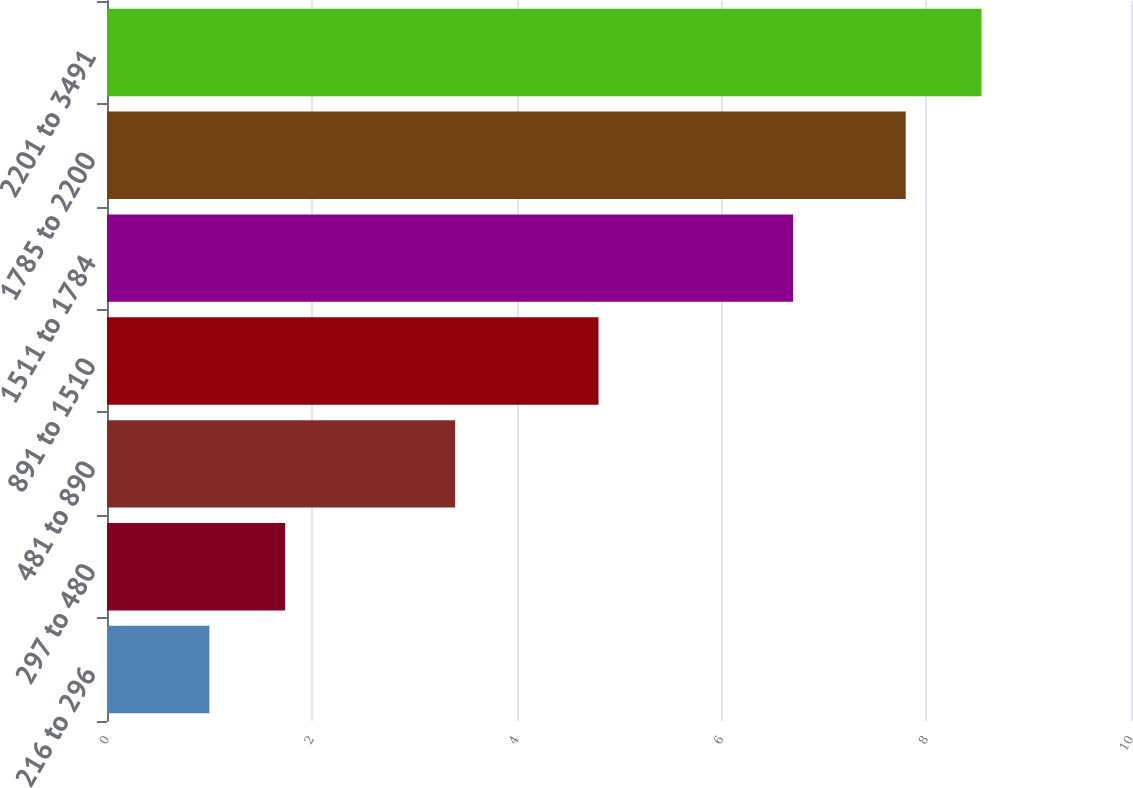Convert chart. <chart><loc_0><loc_0><loc_500><loc_500><bar_chart><fcel>216 to 296<fcel>297 to 480<fcel>481 to 890<fcel>891 to 1510<fcel>1511 to 1784<fcel>1785 to 2200<fcel>2201 to 3491<nl><fcel>1<fcel>1.74<fcel>3.4<fcel>4.8<fcel>6.7<fcel>7.8<fcel>8.54<nl></chart> 